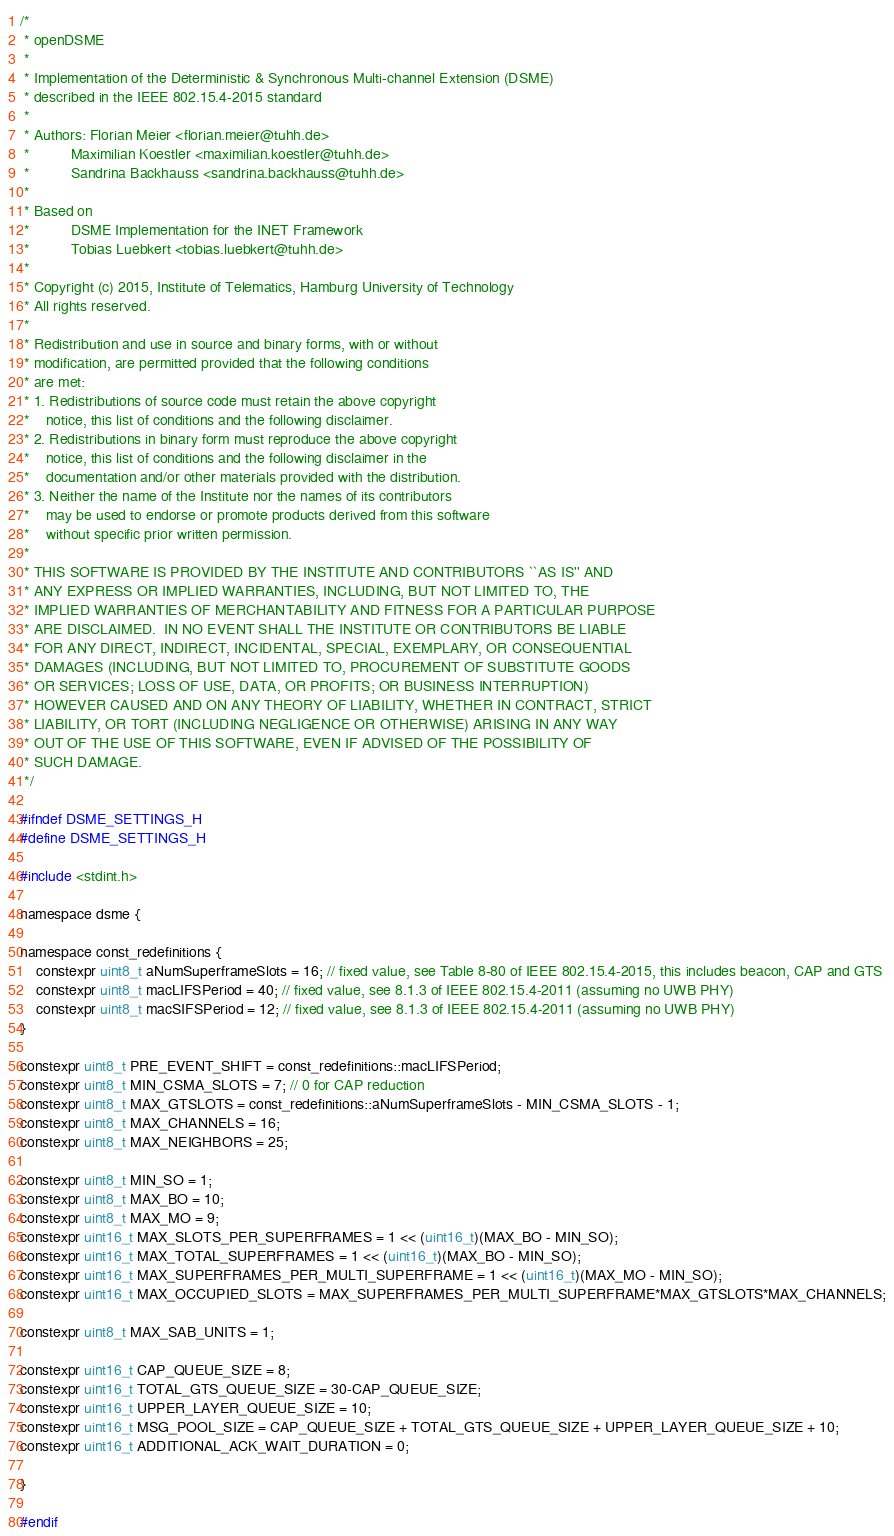Convert code to text. <code><loc_0><loc_0><loc_500><loc_500><_C_>/*
 * openDSME
 *
 * Implementation of the Deterministic & Synchronous Multi-channel Extension (DSME)
 * described in the IEEE 802.15.4-2015 standard
 *
 * Authors: Florian Meier <florian.meier@tuhh.de>
 *          Maximilian Koestler <maximilian.koestler@tuhh.de>
 *          Sandrina Backhauss <sandrina.backhauss@tuhh.de>
 *
 * Based on
 *          DSME Implementation for the INET Framework
 *          Tobias Luebkert <tobias.luebkert@tuhh.de>
 *
 * Copyright (c) 2015, Institute of Telematics, Hamburg University of Technology
 * All rights reserved.
 *
 * Redistribution and use in source and binary forms, with or without
 * modification, are permitted provided that the following conditions
 * are met:
 * 1. Redistributions of source code must retain the above copyright
 *    notice, this list of conditions and the following disclaimer.
 * 2. Redistributions in binary form must reproduce the above copyright
 *    notice, this list of conditions and the following disclaimer in the
 *    documentation and/or other materials provided with the distribution.
 * 3. Neither the name of the Institute nor the names of its contributors
 *    may be used to endorse or promote products derived from this software
 *    without specific prior written permission.
 *
 * THIS SOFTWARE IS PROVIDED BY THE INSTITUTE AND CONTRIBUTORS ``AS IS'' AND
 * ANY EXPRESS OR IMPLIED WARRANTIES, INCLUDING, BUT NOT LIMITED TO, THE
 * IMPLIED WARRANTIES OF MERCHANTABILITY AND FITNESS FOR A PARTICULAR PURPOSE
 * ARE DISCLAIMED.  IN NO EVENT SHALL THE INSTITUTE OR CONTRIBUTORS BE LIABLE
 * FOR ANY DIRECT, INDIRECT, INCIDENTAL, SPECIAL, EXEMPLARY, OR CONSEQUENTIAL
 * DAMAGES (INCLUDING, BUT NOT LIMITED TO, PROCUREMENT OF SUBSTITUTE GOODS
 * OR SERVICES; LOSS OF USE, DATA, OR PROFITS; OR BUSINESS INTERRUPTION)
 * HOWEVER CAUSED AND ON ANY THEORY OF LIABILITY, WHETHER IN CONTRACT, STRICT
 * LIABILITY, OR TORT (INCLUDING NEGLIGENCE OR OTHERWISE) ARISING IN ANY WAY
 * OUT OF THE USE OF THIS SOFTWARE, EVEN IF ADVISED OF THE POSSIBILITY OF
 * SUCH DAMAGE.
 */

#ifndef DSME_SETTINGS_H
#define DSME_SETTINGS_H

#include <stdint.h>

namespace dsme {

namespace const_redefinitions {
    constexpr uint8_t aNumSuperframeSlots = 16; // fixed value, see Table 8-80 of IEEE 802.15.4-2015, this includes beacon, CAP and GTS
    constexpr uint8_t macLIFSPeriod = 40; // fixed value, see 8.1.3 of IEEE 802.15.4-2011 (assuming no UWB PHY)
    constexpr uint8_t macSIFSPeriod = 12; // fixed value, see 8.1.3 of IEEE 802.15.4-2011 (assuming no UWB PHY)
}

constexpr uint8_t PRE_EVENT_SHIFT = const_redefinitions::macLIFSPeriod;
constexpr uint8_t MIN_CSMA_SLOTS = 7; // 0 for CAP reduction
constexpr uint8_t MAX_GTSLOTS = const_redefinitions::aNumSuperframeSlots - MIN_CSMA_SLOTS - 1;
constexpr uint8_t MAX_CHANNELS = 16;
constexpr uint8_t MAX_NEIGHBORS = 25;

constexpr uint8_t MIN_SO = 1;
constexpr uint8_t MAX_BO = 10;
constexpr uint8_t MAX_MO = 9;
constexpr uint16_t MAX_SLOTS_PER_SUPERFRAMES = 1 << (uint16_t)(MAX_BO - MIN_SO);
constexpr uint16_t MAX_TOTAL_SUPERFRAMES = 1 << (uint16_t)(MAX_BO - MIN_SO);
constexpr uint16_t MAX_SUPERFRAMES_PER_MULTI_SUPERFRAME = 1 << (uint16_t)(MAX_MO - MIN_SO);
constexpr uint16_t MAX_OCCUPIED_SLOTS = MAX_SUPERFRAMES_PER_MULTI_SUPERFRAME*MAX_GTSLOTS*MAX_CHANNELS;

constexpr uint8_t MAX_SAB_UNITS = 1;

constexpr uint16_t CAP_QUEUE_SIZE = 8;
constexpr uint16_t TOTAL_GTS_QUEUE_SIZE = 30-CAP_QUEUE_SIZE;
constexpr uint16_t UPPER_LAYER_QUEUE_SIZE = 10;
constexpr uint16_t MSG_POOL_SIZE = CAP_QUEUE_SIZE + TOTAL_GTS_QUEUE_SIZE + UPPER_LAYER_QUEUE_SIZE + 10;
constexpr uint16_t ADDITIONAL_ACK_WAIT_DURATION = 0;

}

#endif
</code> 